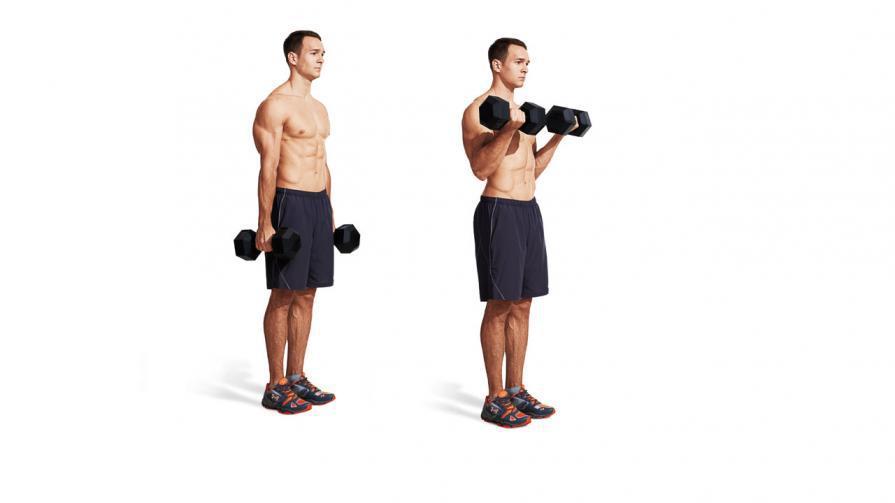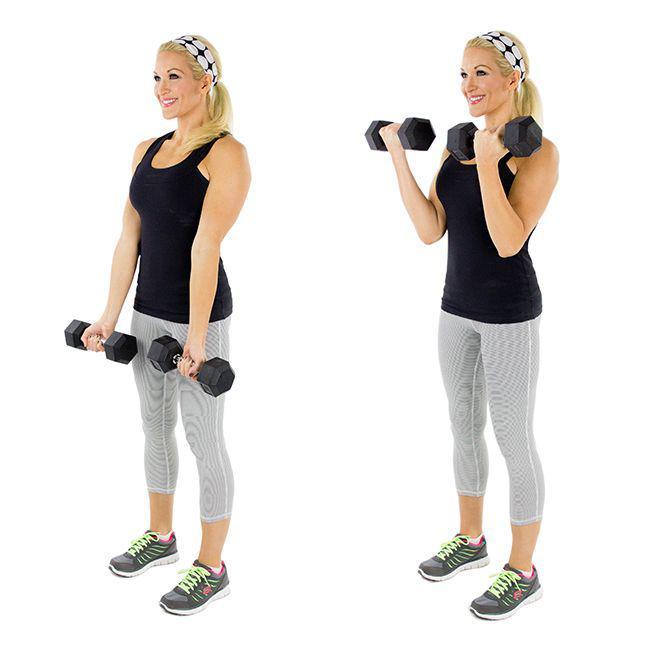The first image is the image on the left, the second image is the image on the right. Considering the images on both sides, is "A man wearing blue short is holding dumbells" valid? Answer yes or no. No. 